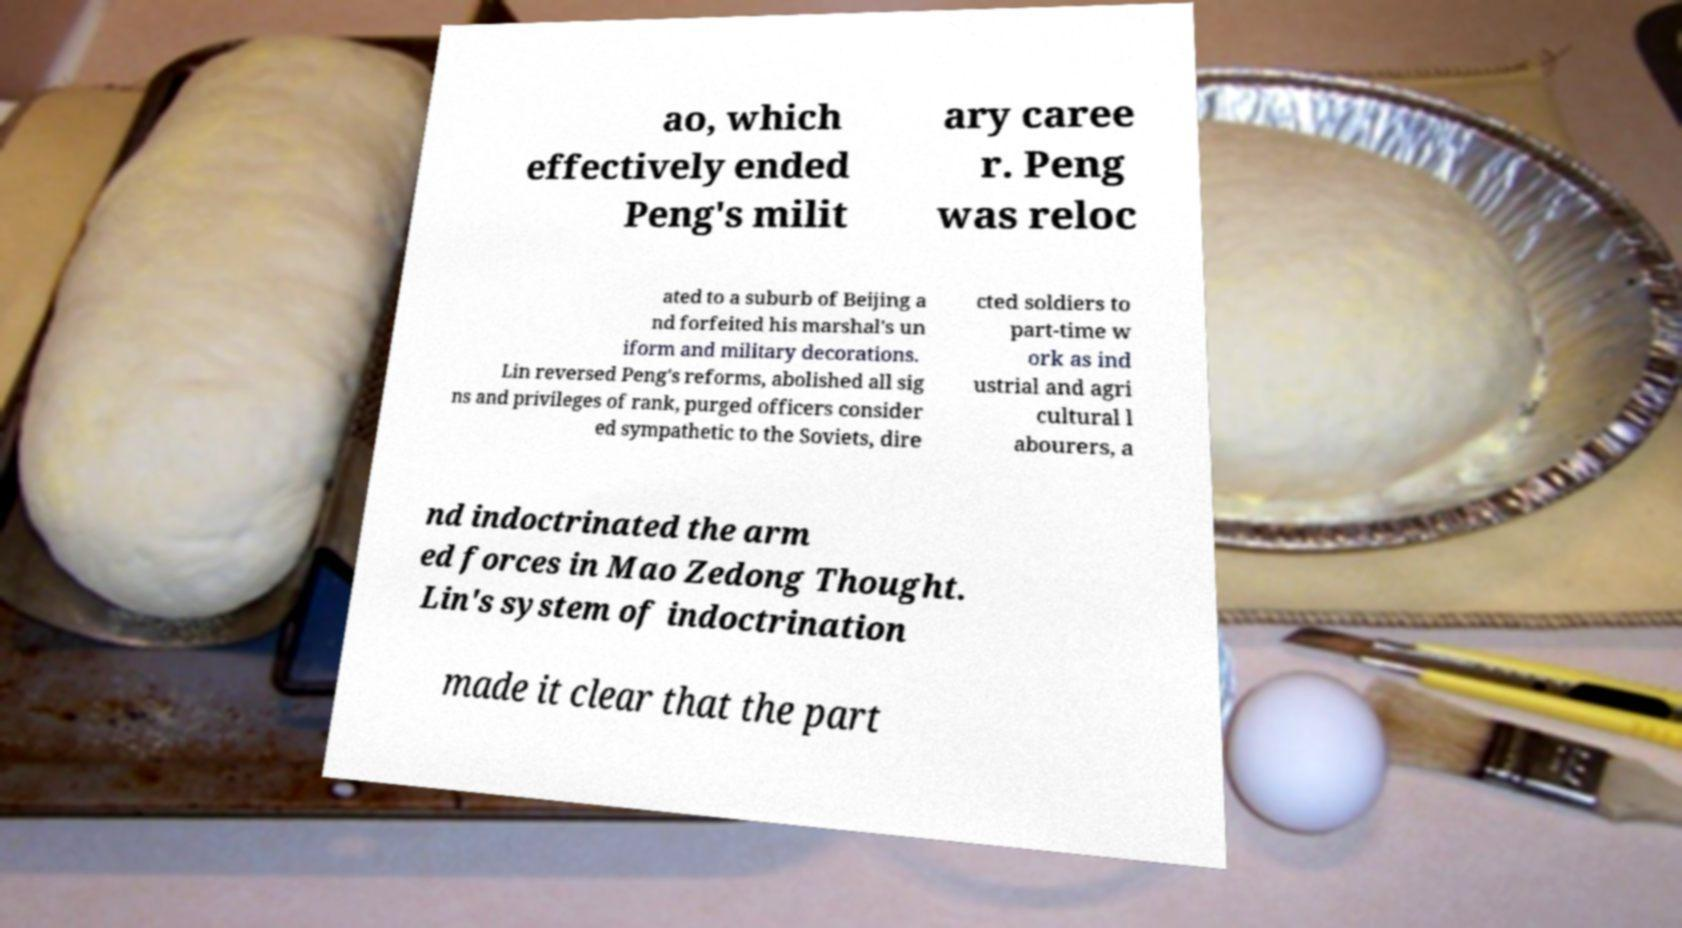Please identify and transcribe the text found in this image. ao, which effectively ended Peng's milit ary caree r. Peng was reloc ated to a suburb of Beijing a nd forfeited his marshal's un iform and military decorations. Lin reversed Peng's reforms, abolished all sig ns and privileges of rank, purged officers consider ed sympathetic to the Soviets, dire cted soldiers to part-time w ork as ind ustrial and agri cultural l abourers, a nd indoctrinated the arm ed forces in Mao Zedong Thought. Lin's system of indoctrination made it clear that the part 